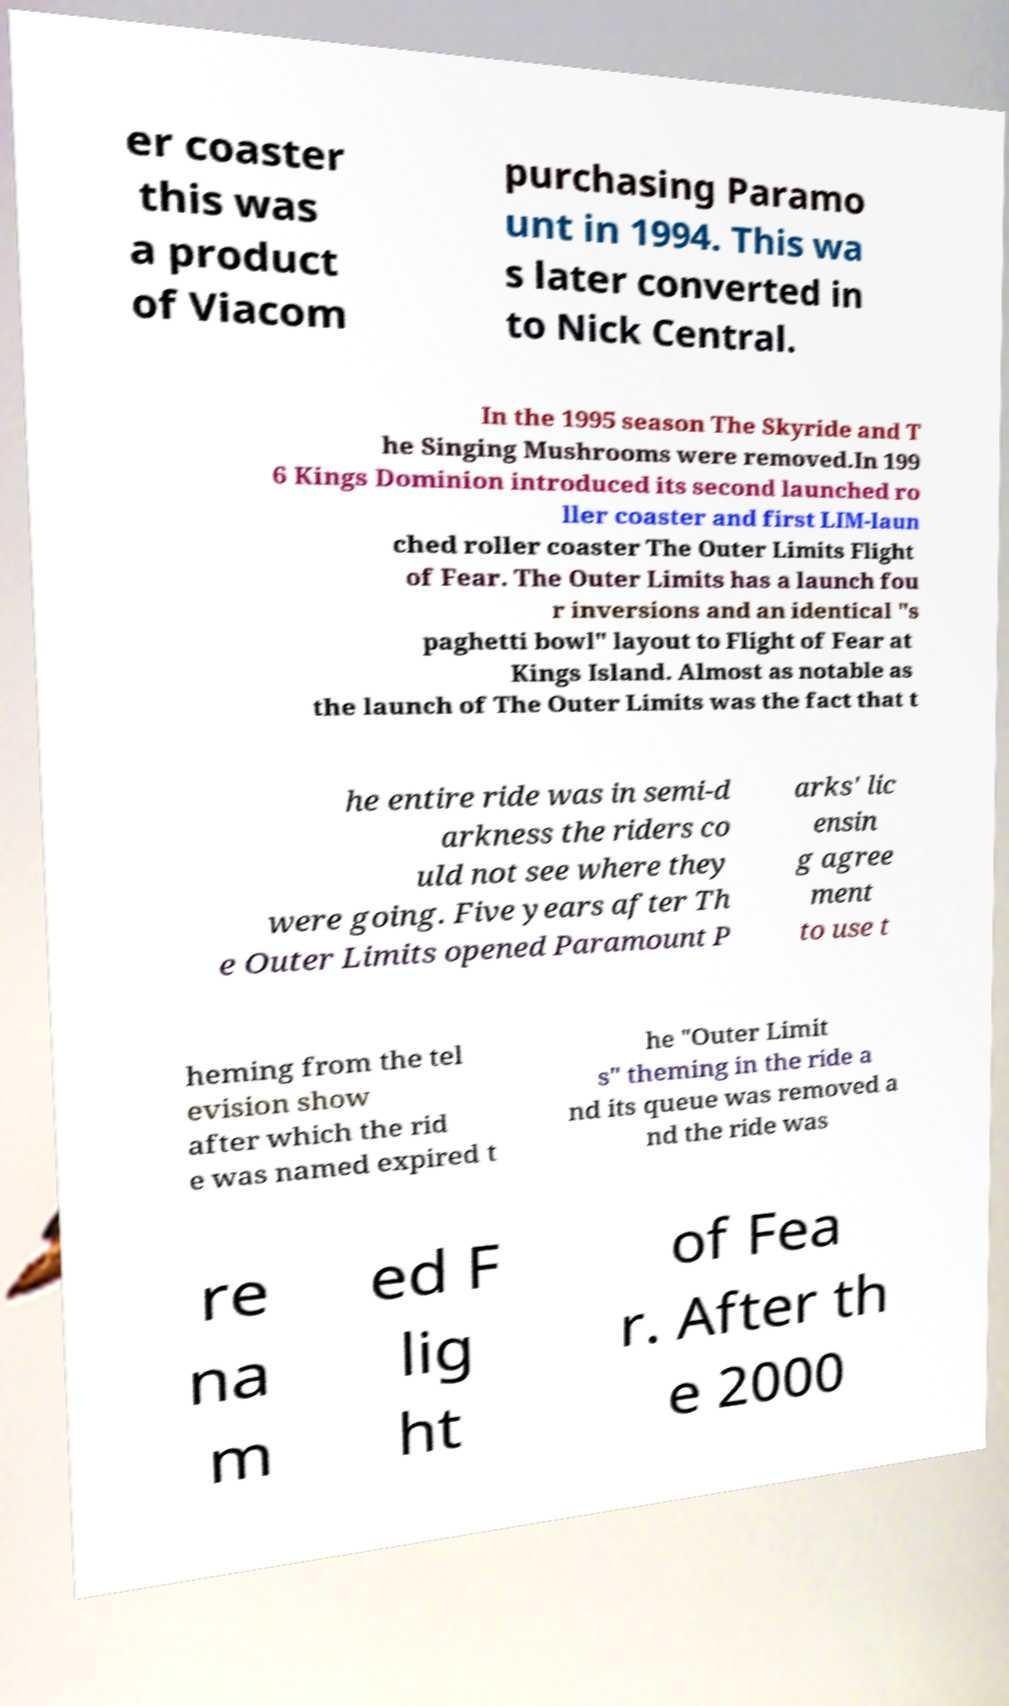Could you extract and type out the text from this image? er coaster this was a product of Viacom purchasing Paramo unt in 1994. This wa s later converted in to Nick Central. In the 1995 season The Skyride and T he Singing Mushrooms were removed.In 199 6 Kings Dominion introduced its second launched ro ller coaster and first LIM-laun ched roller coaster The Outer Limits Flight of Fear. The Outer Limits has a launch fou r inversions and an identical "s paghetti bowl" layout to Flight of Fear at Kings Island. Almost as notable as the launch of The Outer Limits was the fact that t he entire ride was in semi-d arkness the riders co uld not see where they were going. Five years after Th e Outer Limits opened Paramount P arks' lic ensin g agree ment to use t heming from the tel evision show after which the rid e was named expired t he "Outer Limit s" theming in the ride a nd its queue was removed a nd the ride was re na m ed F lig ht of Fea r. After th e 2000 